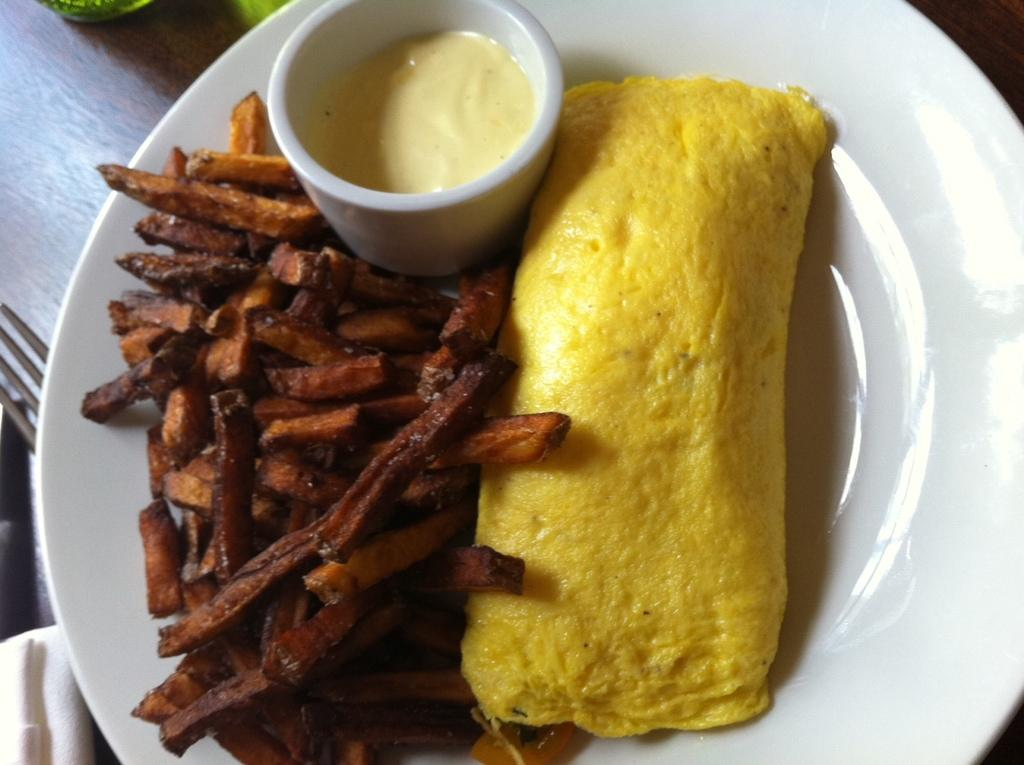What type of items can be seen in the image? There are food items in the image. What is the bowl containing in the image? There is a bowl with sauce in the image. How is the bowl positioned in relation to the plate? The bowl is on a plate in the image. What can be seen in the background of the image? There are objects in the background of the image. Where are the objects located? The objects are on a table in the image. What type of frame is visible around the food items in the image? There is no frame visible around the food items in the image. What kind of toys can be seen on the table with the objects in the image? There are no toys present in the image; only food items, a bowl with sauce, a plate, and objects can be seen on the table. 